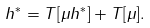<formula> <loc_0><loc_0><loc_500><loc_500>h ^ { * } = T [ \mu h ^ { * } ] + T [ \mu ] .</formula> 